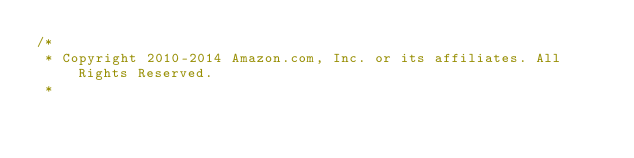<code> <loc_0><loc_0><loc_500><loc_500><_C#_>/*
 * Copyright 2010-2014 Amazon.com, Inc. or its affiliates. All Rights Reserved.
 * </code> 